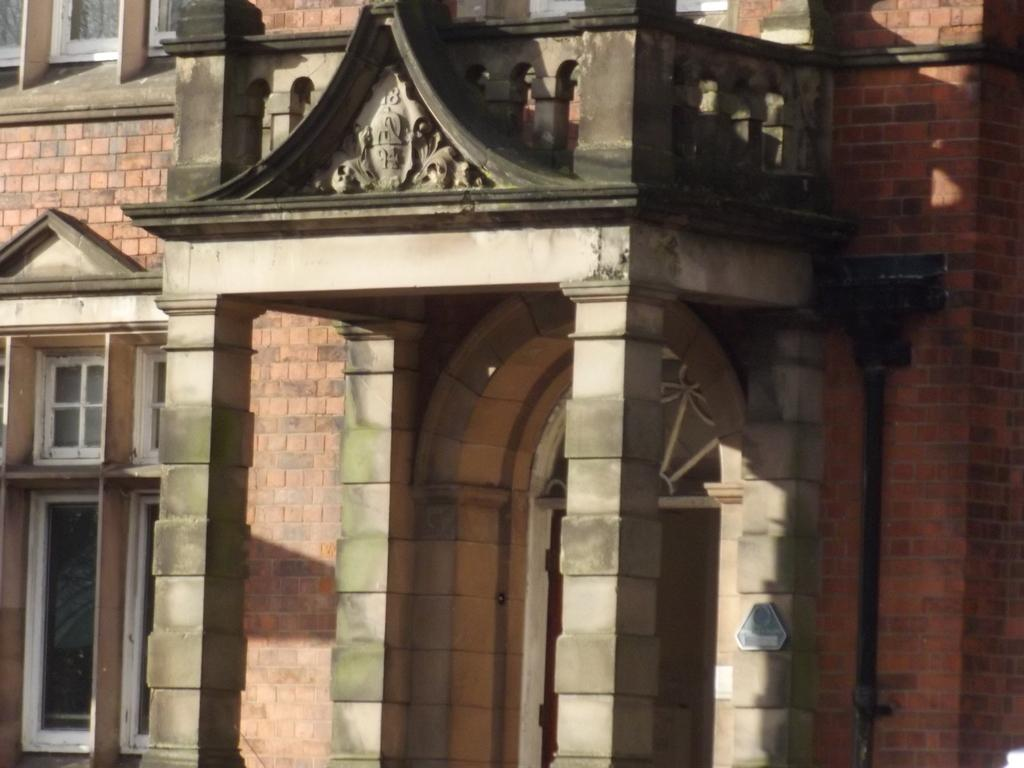What type of structure is present in the image? There is a building in the image. What architectural features can be seen on the building? There are pillars in the image. What openings are visible on the building? There are windows in the image. What type of object is present near the building? There is a pipe in the image. What is the flat, rectangular object in the image? There is a board in the image. How many bikes are parked near the building in the image? There is no mention of bikes in the image; only the building, pillars, windows, pipe, and board are present. What type of ball can be seen bouncing off the board in the image? There is no ball present in the image. 